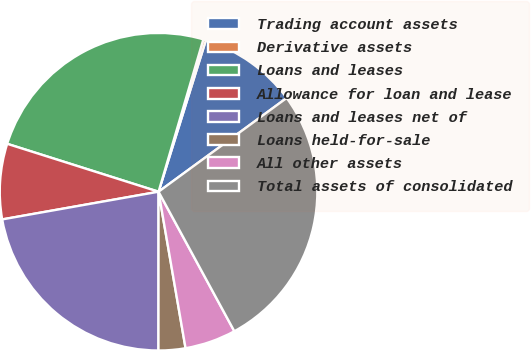<chart> <loc_0><loc_0><loc_500><loc_500><pie_chart><fcel>Trading account assets<fcel>Derivative assets<fcel>Loans and leases<fcel>Allowance for loan and lease<fcel>Loans and leases net of<fcel>Loans held-for-sale<fcel>All other assets<fcel>Total assets of consolidated<nl><fcel>10.13%<fcel>0.27%<fcel>24.67%<fcel>7.67%<fcel>22.2%<fcel>2.73%<fcel>5.2%<fcel>27.13%<nl></chart> 